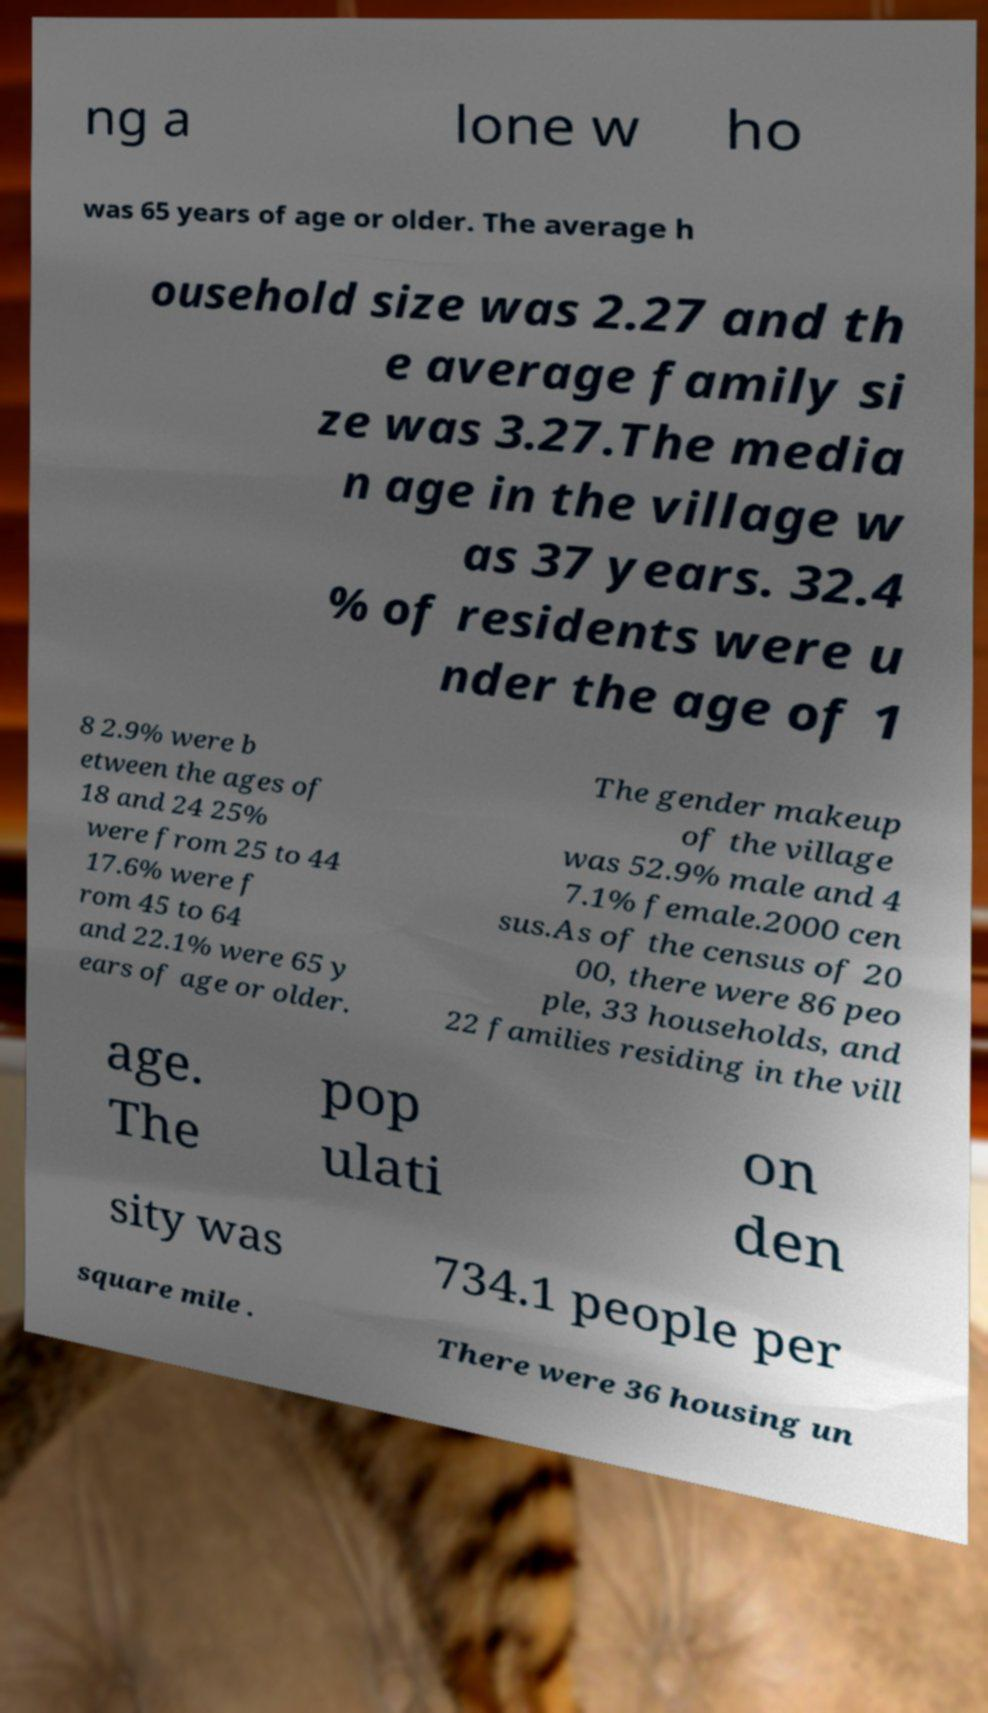What messages or text are displayed in this image? I need them in a readable, typed format. ng a lone w ho was 65 years of age or older. The average h ousehold size was 2.27 and th e average family si ze was 3.27.The media n age in the village w as 37 years. 32.4 % of residents were u nder the age of 1 8 2.9% were b etween the ages of 18 and 24 25% were from 25 to 44 17.6% were f rom 45 to 64 and 22.1% were 65 y ears of age or older. The gender makeup of the village was 52.9% male and 4 7.1% female.2000 cen sus.As of the census of 20 00, there were 86 peo ple, 33 households, and 22 families residing in the vill age. The pop ulati on den sity was 734.1 people per square mile . There were 36 housing un 